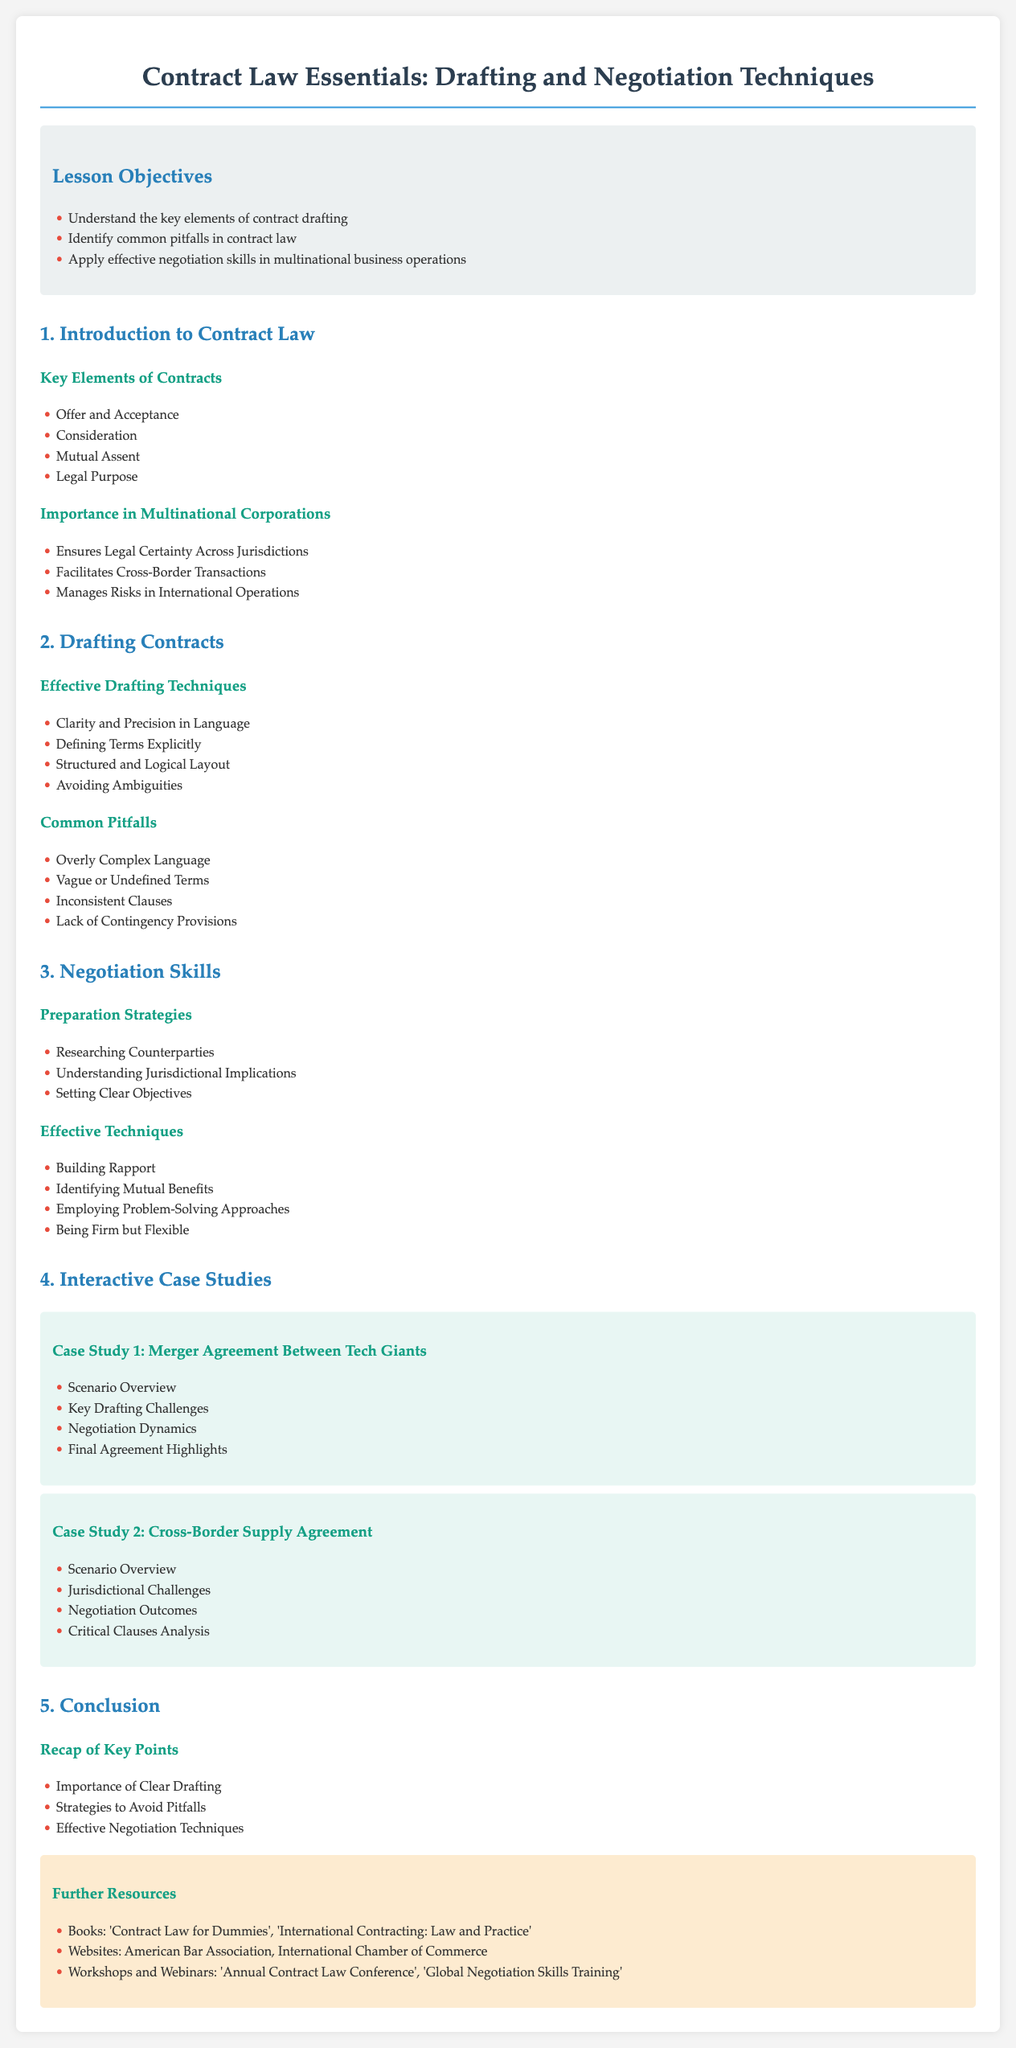What are the key elements of contract drafting? The key elements listed in the document are Offer and Acceptance, Consideration, Mutual Assent, and Legal Purpose.
Answer: Offer and Acceptance, Consideration, Mutual Assent, Legal Purpose What are the common pitfalls in contract law? The document outlines common pitfalls as Overly Complex Language, Vague or Undefined Terms, Inconsistent Clauses, and Lack of Contingency Provisions.
Answer: Overly Complex Language, Vague or Undefined Terms, Inconsistent Clauses, Lack of Contingency Provisions What is an effective negotiation technique? The document mentions Building Rapport as one of the effective techniques in negotiations.
Answer: Building Rapport How many case studies are included in the lesson plan? The document explicitly lists two case studies as part of the interactive learning component.
Answer: Two What importance does contract law serve in multinational corporations? The specified importance includes Ensures Legal Certainty Across Jurisdictions, Facilitates Cross-Border Transactions, and Manages Risks in International Operations.
Answer: Ensures Legal Certainty Across Jurisdictions, Facilitates Cross-Border Transactions, Manages Risks in International Operations What should be defined explicitly in effective drafting techniques? The document emphasizes the importance of Defining Terms Explicitly within effective drafting techniques.
Answer: Defining Terms Explicitly What is one preparation strategy for negotiation? The lesson plan suggests Researching Counterparties as a preparation strategy for negotiations.
Answer: Researching Counterparties What is a resource mentioned for further learning? The document lists 'Contract Law for Dummies' as one of the books for further resources.
Answer: Contract Law for Dummies 